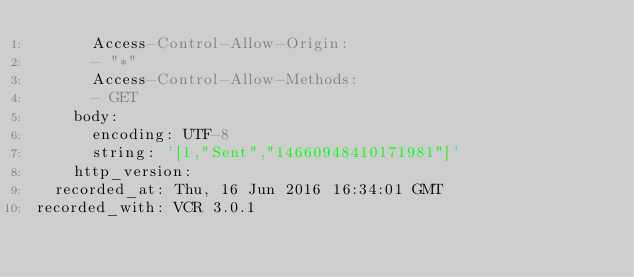Convert code to text. <code><loc_0><loc_0><loc_500><loc_500><_YAML_>      Access-Control-Allow-Origin:
      - "*"
      Access-Control-Allow-Methods:
      - GET
    body:
      encoding: UTF-8
      string: '[1,"Sent","14660948410171981"]'
    http_version: 
  recorded_at: Thu, 16 Jun 2016 16:34:01 GMT
recorded_with: VCR 3.0.1
</code> 